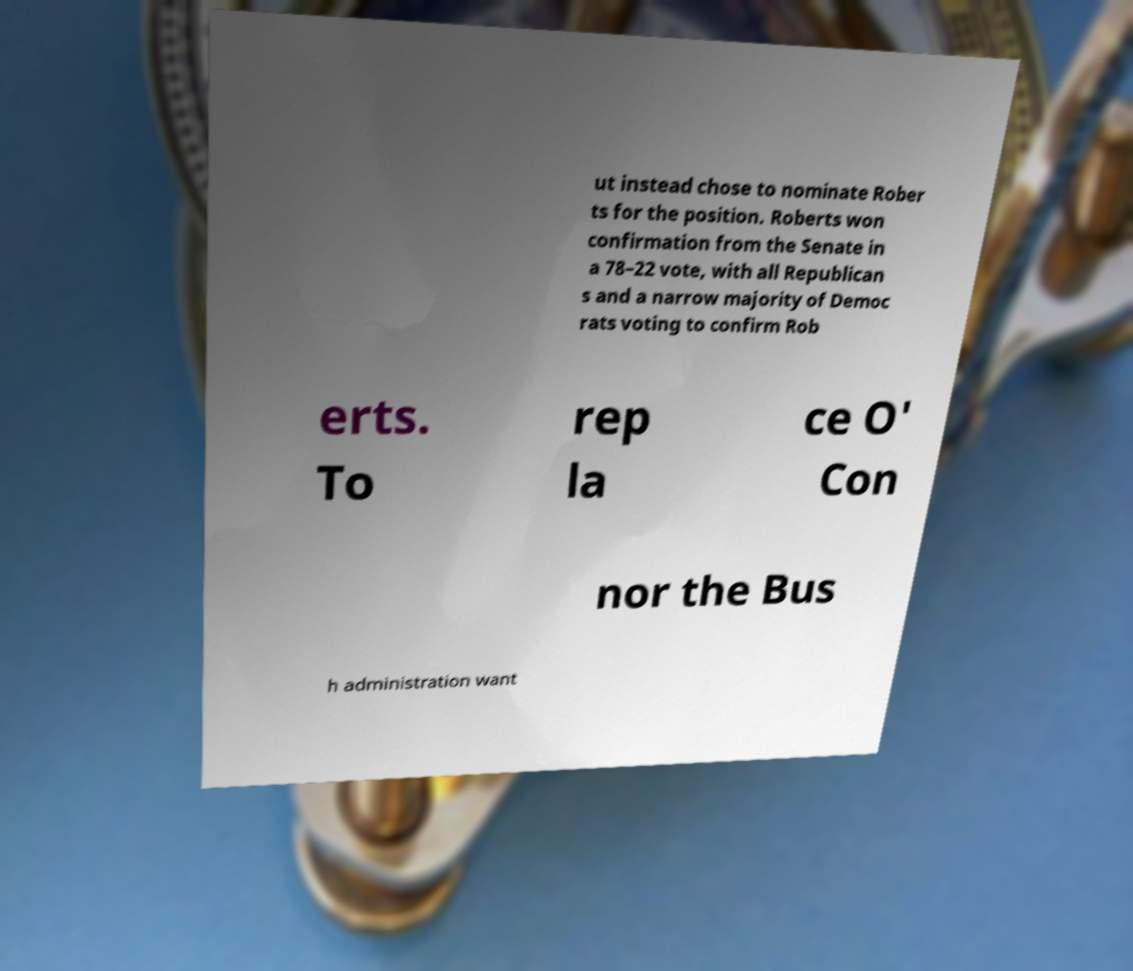Please read and relay the text visible in this image. What does it say? ut instead chose to nominate Rober ts for the position. Roberts won confirmation from the Senate in a 78–22 vote, with all Republican s and a narrow majority of Democ rats voting to confirm Rob erts. To rep la ce O' Con nor the Bus h administration want 